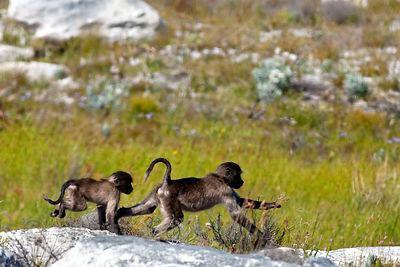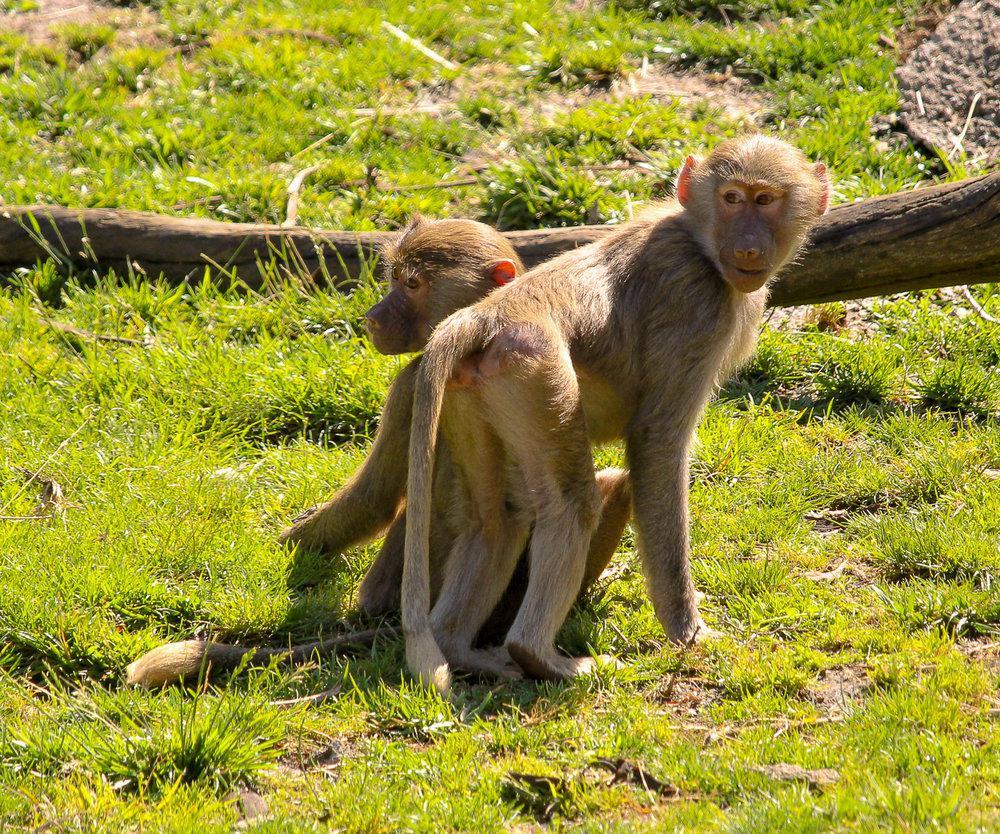The first image is the image on the left, the second image is the image on the right. For the images displayed, is the sentence "There are more than three, but no more than five monkeys." factually correct? Answer yes or no. Yes. The first image is the image on the left, the second image is the image on the right. Considering the images on both sides, is "Three monkeys are in a row on a rock in one image." valid? Answer yes or no. No. 